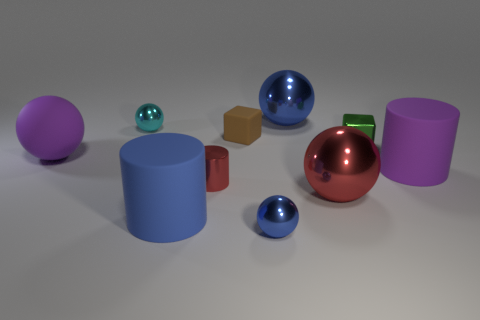Subtract all tiny cylinders. How many cylinders are left? 2 Subtract all blue cylinders. How many blue balls are left? 2 Subtract all blue cylinders. How many cylinders are left? 2 Subtract 3 spheres. How many spheres are left? 2 Subtract all blocks. How many objects are left? 8 Subtract 1 brown cubes. How many objects are left? 9 Subtract all cyan balls. Subtract all cyan cubes. How many balls are left? 4 Subtract all purple cylinders. Subtract all large green metal blocks. How many objects are left? 9 Add 5 purple matte balls. How many purple matte balls are left? 6 Add 4 gray shiny cylinders. How many gray shiny cylinders exist? 4 